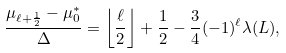<formula> <loc_0><loc_0><loc_500><loc_500>\frac { \mu _ { \ell + \frac { 1 } { 2 } } - \mu _ { 0 } ^ { * } } { \Delta } = \left \lfloor \frac { \ell } { 2 } \right \rfloor + \frac { 1 } { 2 } - \frac { 3 } { 4 } ( - 1 ) ^ { \ell } \lambda ( L ) ,</formula> 